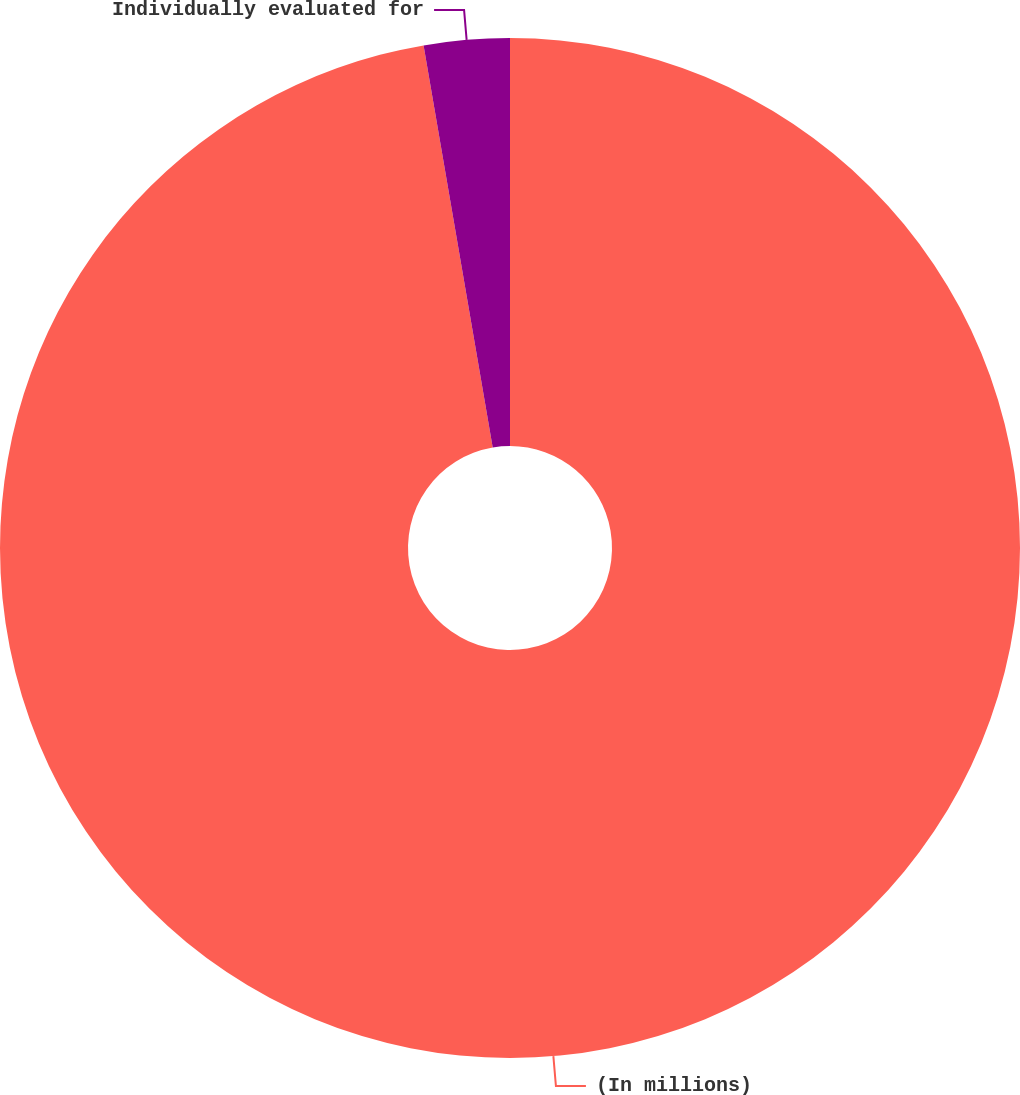Convert chart to OTSL. <chart><loc_0><loc_0><loc_500><loc_500><pie_chart><fcel>(In millions)<fcel>Individually evaluated for<nl><fcel>97.29%<fcel>2.71%<nl></chart> 